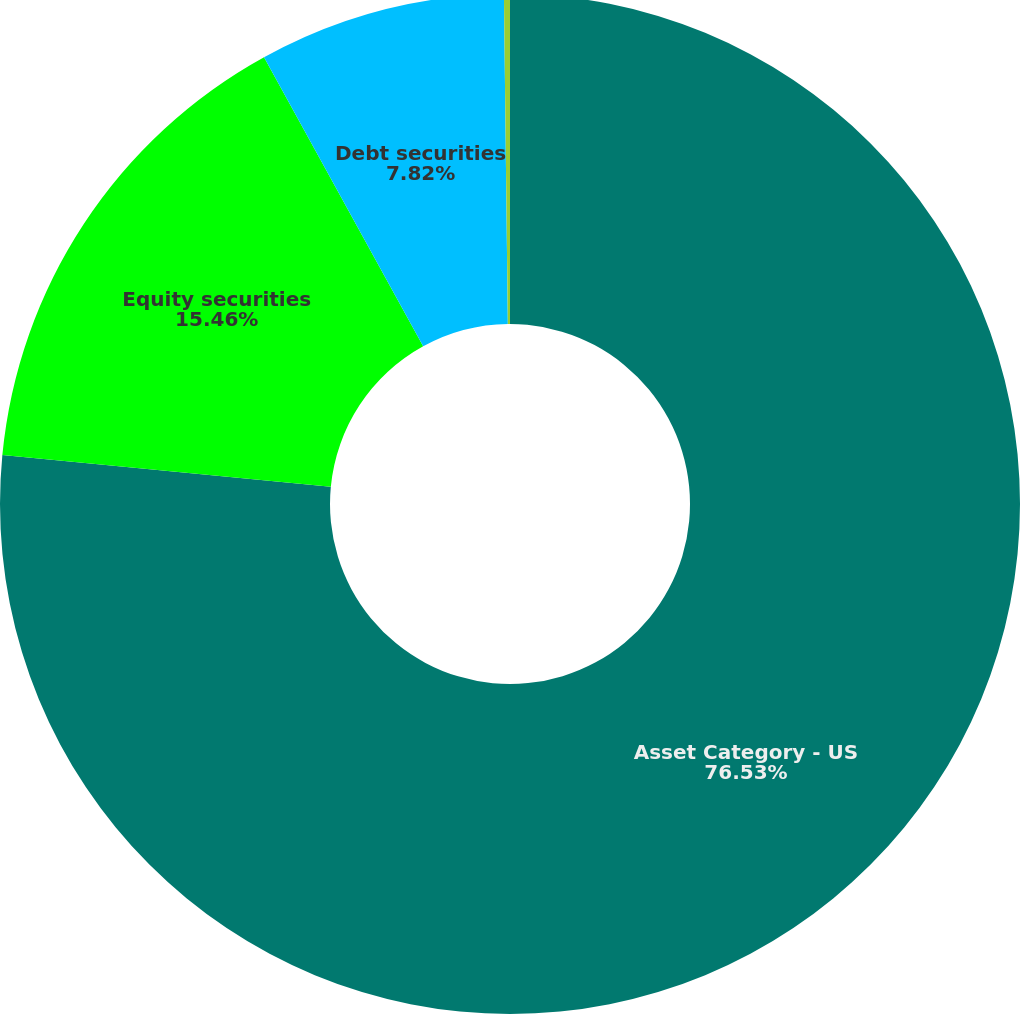Convert chart to OTSL. <chart><loc_0><loc_0><loc_500><loc_500><pie_chart><fcel>Asset Category - US<fcel>Equity securities<fcel>Debt securities<fcel>Real estate and other<nl><fcel>76.53%<fcel>15.46%<fcel>7.82%<fcel>0.19%<nl></chart> 